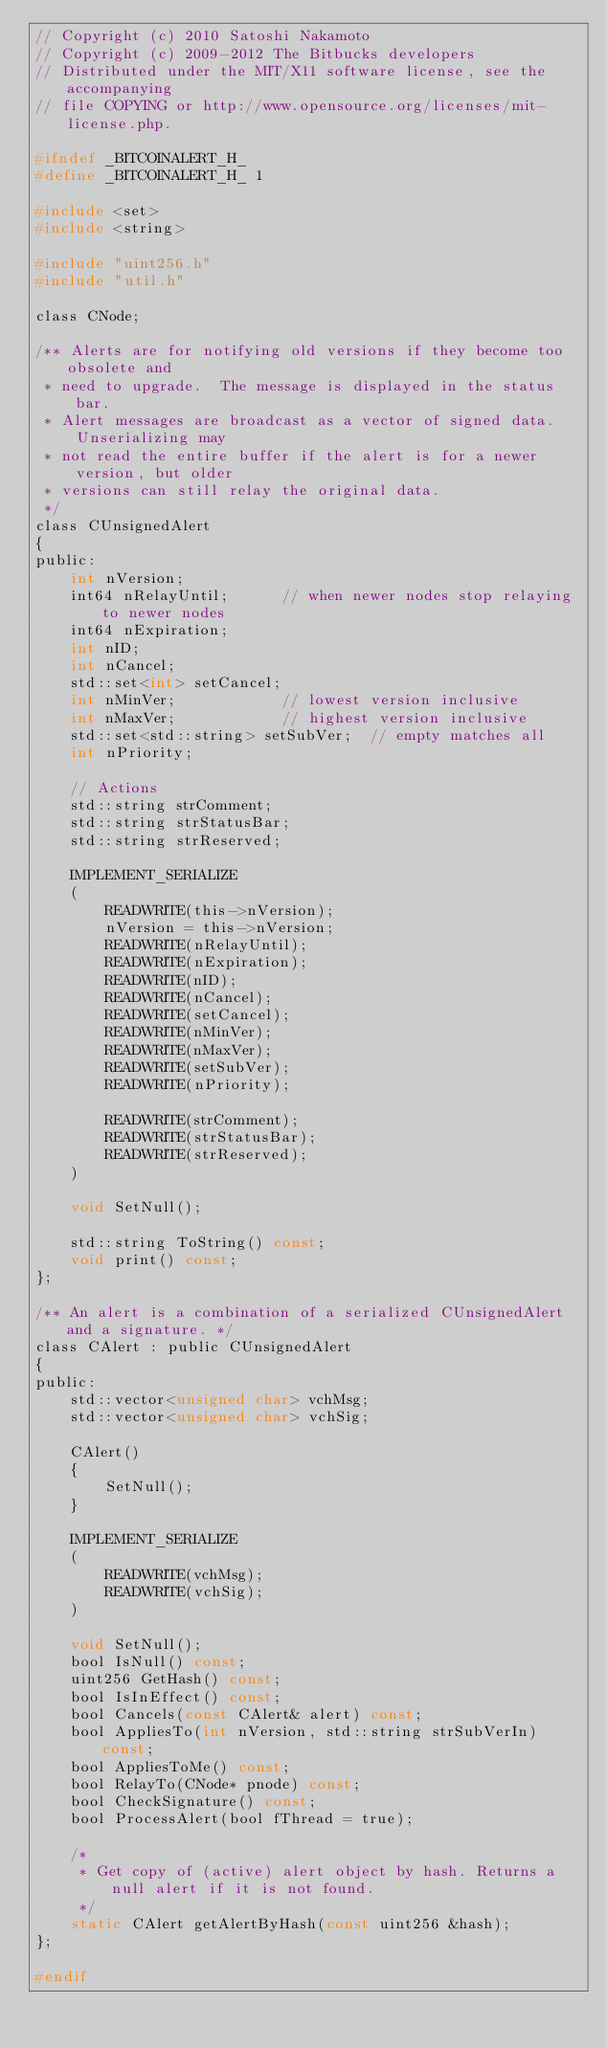<code> <loc_0><loc_0><loc_500><loc_500><_C_>// Copyright (c) 2010 Satoshi Nakamoto
// Copyright (c) 2009-2012 The Bitbucks developers
// Distributed under the MIT/X11 software license, see the accompanying
// file COPYING or http://www.opensource.org/licenses/mit-license.php.

#ifndef _BITCOINALERT_H_
#define _BITCOINALERT_H_ 1

#include <set>
#include <string>

#include "uint256.h"
#include "util.h"

class CNode;

/** Alerts are for notifying old versions if they become too obsolete and
 * need to upgrade.  The message is displayed in the status bar.
 * Alert messages are broadcast as a vector of signed data.  Unserializing may
 * not read the entire buffer if the alert is for a newer version, but older
 * versions can still relay the original data.
 */
class CUnsignedAlert
{
public:
    int nVersion;
    int64 nRelayUntil;      // when newer nodes stop relaying to newer nodes
    int64 nExpiration;
    int nID;
    int nCancel;
    std::set<int> setCancel;
    int nMinVer;            // lowest version inclusive
    int nMaxVer;            // highest version inclusive
    std::set<std::string> setSubVer;  // empty matches all
    int nPriority;

    // Actions
    std::string strComment;
    std::string strStatusBar;
    std::string strReserved;

    IMPLEMENT_SERIALIZE
    (
        READWRITE(this->nVersion);
        nVersion = this->nVersion;
        READWRITE(nRelayUntil);
        READWRITE(nExpiration);
        READWRITE(nID);
        READWRITE(nCancel);
        READWRITE(setCancel);
        READWRITE(nMinVer);
        READWRITE(nMaxVer);
        READWRITE(setSubVer);
        READWRITE(nPriority);

        READWRITE(strComment);
        READWRITE(strStatusBar);
        READWRITE(strReserved);
    )

    void SetNull();

    std::string ToString() const;
    void print() const;
};

/** An alert is a combination of a serialized CUnsignedAlert and a signature. */
class CAlert : public CUnsignedAlert
{
public:
    std::vector<unsigned char> vchMsg;
    std::vector<unsigned char> vchSig;

    CAlert()
    {
        SetNull();
    }

    IMPLEMENT_SERIALIZE
    (
        READWRITE(vchMsg);
        READWRITE(vchSig);
    )

    void SetNull();
    bool IsNull() const;
    uint256 GetHash() const;
    bool IsInEffect() const;
    bool Cancels(const CAlert& alert) const;
    bool AppliesTo(int nVersion, std::string strSubVerIn) const;
    bool AppliesToMe() const;
    bool RelayTo(CNode* pnode) const;
    bool CheckSignature() const;
    bool ProcessAlert(bool fThread = true);

    /*
     * Get copy of (active) alert object by hash. Returns a null alert if it is not found.
     */
    static CAlert getAlertByHash(const uint256 &hash);
};

#endif
</code> 